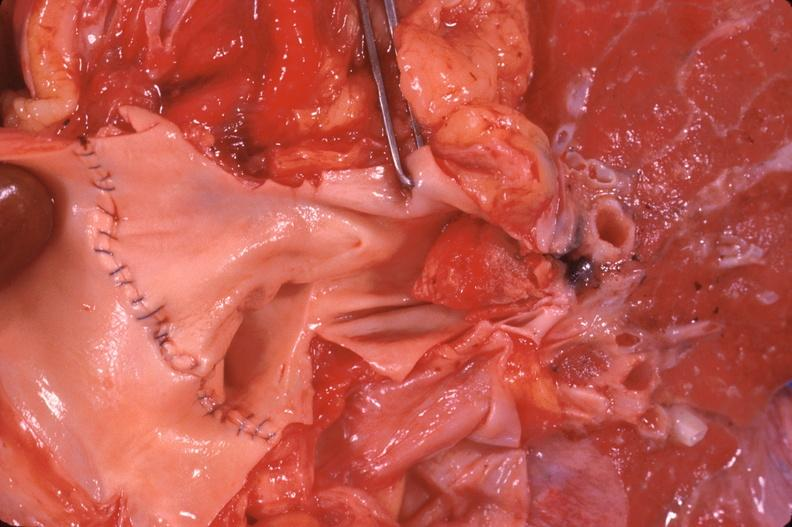where is this?
Answer the question using a single word or phrase. Lung 